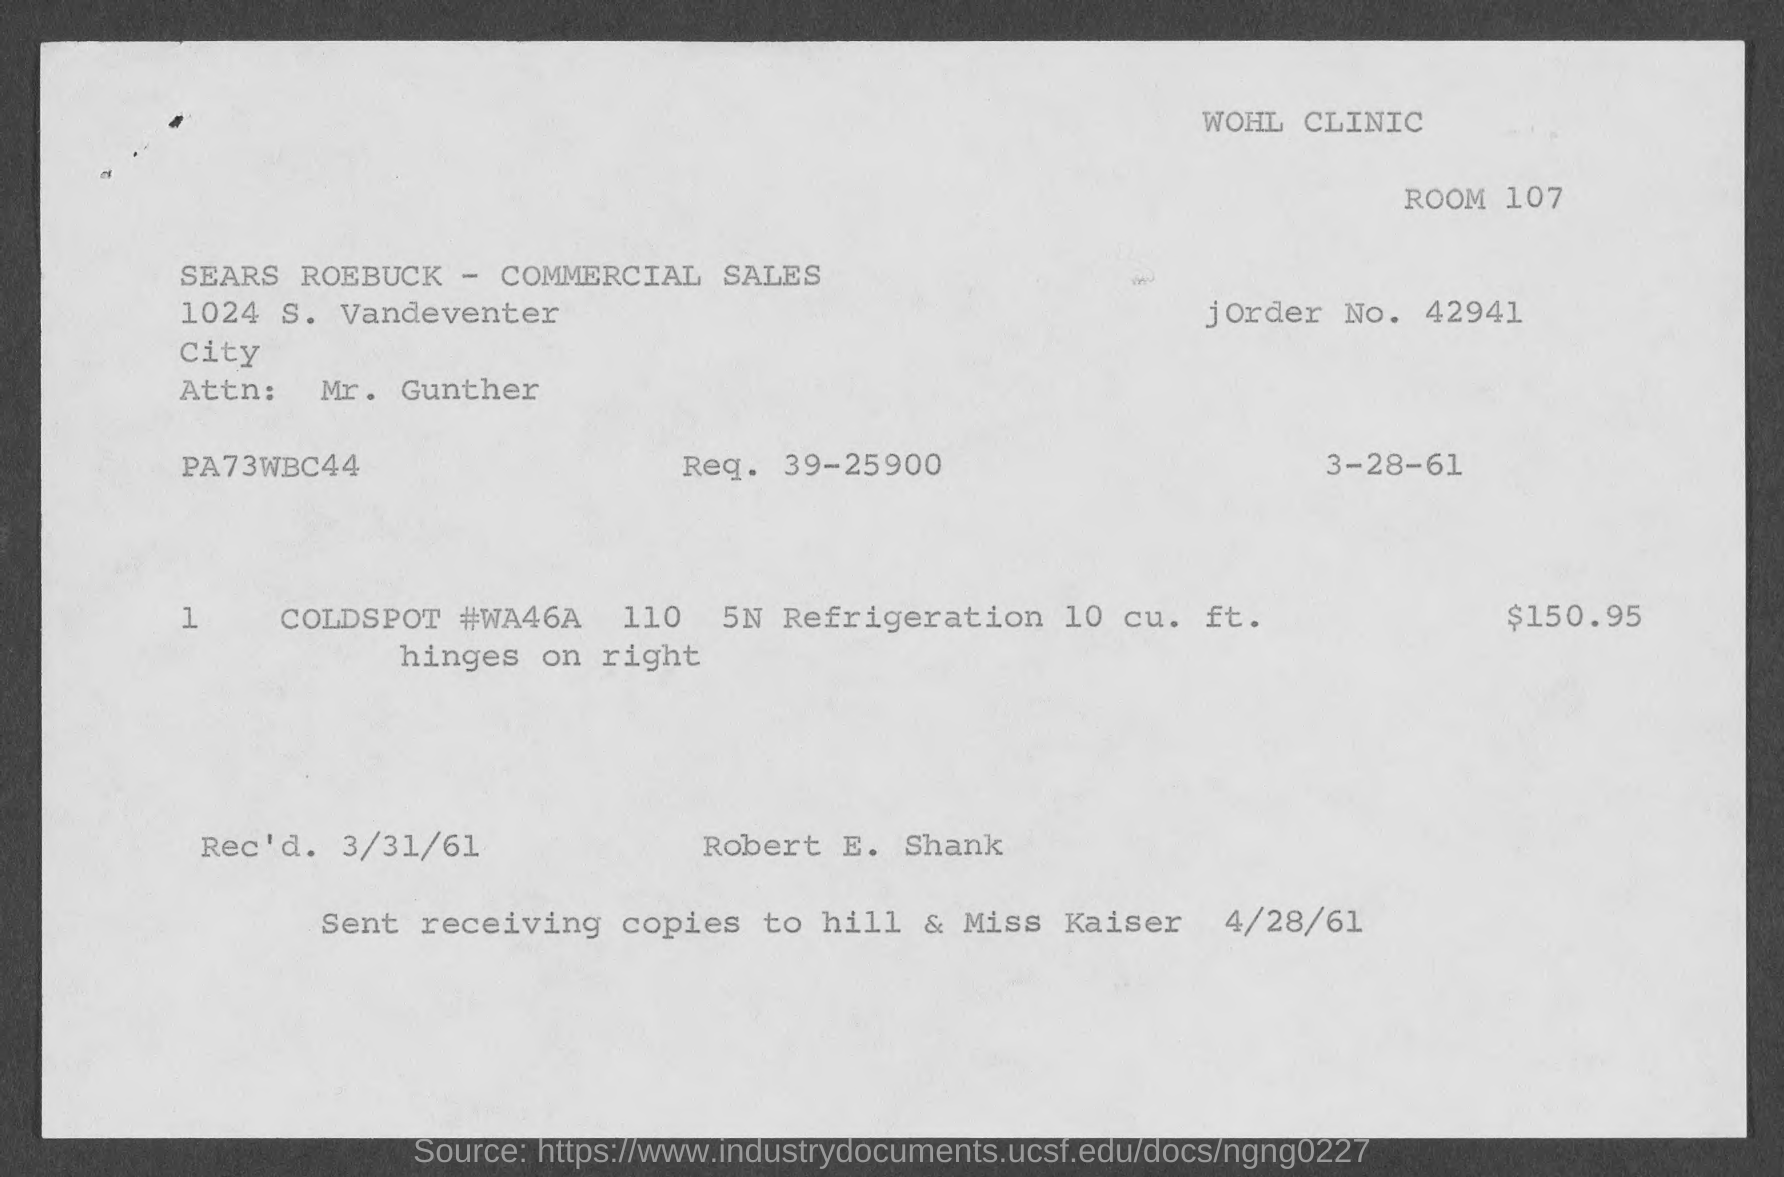What is the room no mentioned in the given page ?
Your answer should be very brief. 107. What is the j order no. mentioned in the given page ?
Provide a short and direct response. 42941. What is the req. mentioned in the given form ?
Provide a succinct answer. 39-25900. What is the amount mentioned in the given form ?
Give a very brief answer. $ 150.95. What is the rec'd date mentioned in the given page ?
Keep it short and to the point. 3/31/61. 